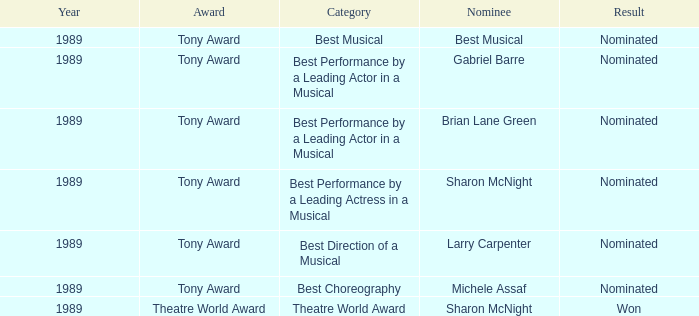What year was michele assaf nominated 1989.0. 